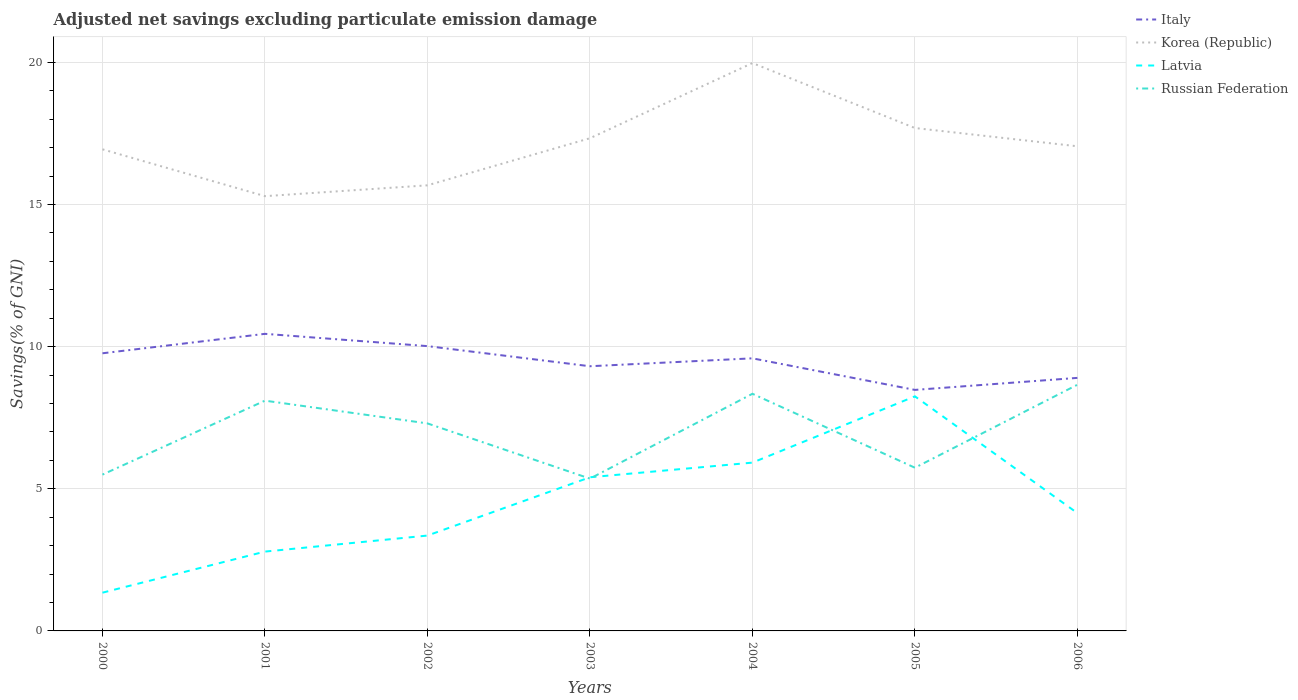How many different coloured lines are there?
Make the answer very short. 4. Across all years, what is the maximum adjusted net savings in Italy?
Your response must be concise. 8.48. What is the total adjusted net savings in Latvia in the graph?
Offer a terse response. 1.78. What is the difference between the highest and the second highest adjusted net savings in Korea (Republic)?
Your answer should be very brief. 4.68. Is the adjusted net savings in Russian Federation strictly greater than the adjusted net savings in Korea (Republic) over the years?
Keep it short and to the point. Yes. How many lines are there?
Your answer should be compact. 4. Does the graph contain any zero values?
Provide a succinct answer. No. Does the graph contain grids?
Make the answer very short. Yes. Where does the legend appear in the graph?
Your answer should be compact. Top right. How many legend labels are there?
Ensure brevity in your answer.  4. What is the title of the graph?
Ensure brevity in your answer.  Adjusted net savings excluding particulate emission damage. Does "Kazakhstan" appear as one of the legend labels in the graph?
Your answer should be very brief. No. What is the label or title of the Y-axis?
Provide a short and direct response. Savings(% of GNI). What is the Savings(% of GNI) of Italy in 2000?
Ensure brevity in your answer.  9.77. What is the Savings(% of GNI) in Korea (Republic) in 2000?
Provide a succinct answer. 16.94. What is the Savings(% of GNI) of Latvia in 2000?
Offer a very short reply. 1.35. What is the Savings(% of GNI) in Russian Federation in 2000?
Give a very brief answer. 5.5. What is the Savings(% of GNI) of Italy in 2001?
Give a very brief answer. 10.45. What is the Savings(% of GNI) in Korea (Republic) in 2001?
Your response must be concise. 15.29. What is the Savings(% of GNI) of Latvia in 2001?
Your answer should be compact. 2.79. What is the Savings(% of GNI) of Russian Federation in 2001?
Provide a short and direct response. 8.1. What is the Savings(% of GNI) of Italy in 2002?
Your answer should be compact. 10.02. What is the Savings(% of GNI) of Korea (Republic) in 2002?
Provide a succinct answer. 15.67. What is the Savings(% of GNI) in Latvia in 2002?
Ensure brevity in your answer.  3.35. What is the Savings(% of GNI) of Russian Federation in 2002?
Provide a short and direct response. 7.3. What is the Savings(% of GNI) of Italy in 2003?
Your answer should be very brief. 9.31. What is the Savings(% of GNI) of Korea (Republic) in 2003?
Make the answer very short. 17.33. What is the Savings(% of GNI) in Latvia in 2003?
Your answer should be very brief. 5.41. What is the Savings(% of GNI) of Russian Federation in 2003?
Provide a succinct answer. 5.36. What is the Savings(% of GNI) of Italy in 2004?
Make the answer very short. 9.59. What is the Savings(% of GNI) of Korea (Republic) in 2004?
Your response must be concise. 19.98. What is the Savings(% of GNI) in Latvia in 2004?
Your answer should be very brief. 5.92. What is the Savings(% of GNI) in Russian Federation in 2004?
Provide a short and direct response. 8.34. What is the Savings(% of GNI) of Italy in 2005?
Make the answer very short. 8.48. What is the Savings(% of GNI) of Korea (Republic) in 2005?
Offer a very short reply. 17.69. What is the Savings(% of GNI) of Latvia in 2005?
Your answer should be compact. 8.25. What is the Savings(% of GNI) of Russian Federation in 2005?
Your answer should be compact. 5.74. What is the Savings(% of GNI) of Italy in 2006?
Make the answer very short. 8.9. What is the Savings(% of GNI) in Korea (Republic) in 2006?
Provide a succinct answer. 17.05. What is the Savings(% of GNI) in Latvia in 2006?
Keep it short and to the point. 4.14. What is the Savings(% of GNI) of Russian Federation in 2006?
Give a very brief answer. 8.66. Across all years, what is the maximum Savings(% of GNI) in Italy?
Your answer should be compact. 10.45. Across all years, what is the maximum Savings(% of GNI) of Korea (Republic)?
Make the answer very short. 19.98. Across all years, what is the maximum Savings(% of GNI) in Latvia?
Your answer should be very brief. 8.25. Across all years, what is the maximum Savings(% of GNI) of Russian Federation?
Offer a very short reply. 8.66. Across all years, what is the minimum Savings(% of GNI) in Italy?
Provide a succinct answer. 8.48. Across all years, what is the minimum Savings(% of GNI) in Korea (Republic)?
Keep it short and to the point. 15.29. Across all years, what is the minimum Savings(% of GNI) of Latvia?
Offer a terse response. 1.35. Across all years, what is the minimum Savings(% of GNI) of Russian Federation?
Your answer should be very brief. 5.36. What is the total Savings(% of GNI) in Italy in the graph?
Ensure brevity in your answer.  66.51. What is the total Savings(% of GNI) in Korea (Republic) in the graph?
Your answer should be compact. 119.95. What is the total Savings(% of GNI) in Latvia in the graph?
Your answer should be very brief. 31.21. What is the total Savings(% of GNI) in Russian Federation in the graph?
Your answer should be very brief. 49. What is the difference between the Savings(% of GNI) in Italy in 2000 and that in 2001?
Offer a terse response. -0.68. What is the difference between the Savings(% of GNI) of Korea (Republic) in 2000 and that in 2001?
Keep it short and to the point. 1.65. What is the difference between the Savings(% of GNI) in Latvia in 2000 and that in 2001?
Provide a short and direct response. -1.45. What is the difference between the Savings(% of GNI) in Russian Federation in 2000 and that in 2001?
Your response must be concise. -2.6. What is the difference between the Savings(% of GNI) in Italy in 2000 and that in 2002?
Make the answer very short. -0.25. What is the difference between the Savings(% of GNI) in Korea (Republic) in 2000 and that in 2002?
Provide a succinct answer. 1.27. What is the difference between the Savings(% of GNI) of Latvia in 2000 and that in 2002?
Offer a very short reply. -2.01. What is the difference between the Savings(% of GNI) of Russian Federation in 2000 and that in 2002?
Your response must be concise. -1.8. What is the difference between the Savings(% of GNI) in Italy in 2000 and that in 2003?
Provide a short and direct response. 0.46. What is the difference between the Savings(% of GNI) of Korea (Republic) in 2000 and that in 2003?
Offer a terse response. -0.39. What is the difference between the Savings(% of GNI) in Latvia in 2000 and that in 2003?
Ensure brevity in your answer.  -4.06. What is the difference between the Savings(% of GNI) in Russian Federation in 2000 and that in 2003?
Your answer should be compact. 0.14. What is the difference between the Savings(% of GNI) in Italy in 2000 and that in 2004?
Offer a very short reply. 0.18. What is the difference between the Savings(% of GNI) in Korea (Republic) in 2000 and that in 2004?
Give a very brief answer. -3.03. What is the difference between the Savings(% of GNI) in Latvia in 2000 and that in 2004?
Provide a succinct answer. -4.57. What is the difference between the Savings(% of GNI) of Russian Federation in 2000 and that in 2004?
Offer a terse response. -2.84. What is the difference between the Savings(% of GNI) of Italy in 2000 and that in 2005?
Offer a terse response. 1.29. What is the difference between the Savings(% of GNI) in Korea (Republic) in 2000 and that in 2005?
Your answer should be compact. -0.75. What is the difference between the Savings(% of GNI) of Latvia in 2000 and that in 2005?
Your response must be concise. -6.91. What is the difference between the Savings(% of GNI) of Russian Federation in 2000 and that in 2005?
Provide a short and direct response. -0.24. What is the difference between the Savings(% of GNI) of Italy in 2000 and that in 2006?
Make the answer very short. 0.87. What is the difference between the Savings(% of GNI) of Korea (Republic) in 2000 and that in 2006?
Provide a short and direct response. -0.11. What is the difference between the Savings(% of GNI) in Latvia in 2000 and that in 2006?
Give a very brief answer. -2.8. What is the difference between the Savings(% of GNI) in Russian Federation in 2000 and that in 2006?
Ensure brevity in your answer.  -3.16. What is the difference between the Savings(% of GNI) in Italy in 2001 and that in 2002?
Ensure brevity in your answer.  0.43. What is the difference between the Savings(% of GNI) of Korea (Republic) in 2001 and that in 2002?
Provide a short and direct response. -0.38. What is the difference between the Savings(% of GNI) in Latvia in 2001 and that in 2002?
Provide a short and direct response. -0.56. What is the difference between the Savings(% of GNI) of Russian Federation in 2001 and that in 2002?
Give a very brief answer. 0.8. What is the difference between the Savings(% of GNI) in Italy in 2001 and that in 2003?
Offer a very short reply. 1.14. What is the difference between the Savings(% of GNI) of Korea (Republic) in 2001 and that in 2003?
Your response must be concise. -2.04. What is the difference between the Savings(% of GNI) of Latvia in 2001 and that in 2003?
Give a very brief answer. -2.61. What is the difference between the Savings(% of GNI) of Russian Federation in 2001 and that in 2003?
Make the answer very short. 2.74. What is the difference between the Savings(% of GNI) in Italy in 2001 and that in 2004?
Give a very brief answer. 0.86. What is the difference between the Savings(% of GNI) in Korea (Republic) in 2001 and that in 2004?
Your answer should be very brief. -4.68. What is the difference between the Savings(% of GNI) of Latvia in 2001 and that in 2004?
Keep it short and to the point. -3.13. What is the difference between the Savings(% of GNI) of Russian Federation in 2001 and that in 2004?
Offer a very short reply. -0.24. What is the difference between the Savings(% of GNI) of Italy in 2001 and that in 2005?
Make the answer very short. 1.97. What is the difference between the Savings(% of GNI) of Korea (Republic) in 2001 and that in 2005?
Provide a short and direct response. -2.4. What is the difference between the Savings(% of GNI) of Latvia in 2001 and that in 2005?
Provide a succinct answer. -5.46. What is the difference between the Savings(% of GNI) of Russian Federation in 2001 and that in 2005?
Your response must be concise. 2.36. What is the difference between the Savings(% of GNI) in Italy in 2001 and that in 2006?
Your answer should be very brief. 1.55. What is the difference between the Savings(% of GNI) in Korea (Republic) in 2001 and that in 2006?
Provide a succinct answer. -1.75. What is the difference between the Savings(% of GNI) of Latvia in 2001 and that in 2006?
Ensure brevity in your answer.  -1.35. What is the difference between the Savings(% of GNI) of Russian Federation in 2001 and that in 2006?
Your response must be concise. -0.56. What is the difference between the Savings(% of GNI) of Italy in 2002 and that in 2003?
Give a very brief answer. 0.71. What is the difference between the Savings(% of GNI) in Korea (Republic) in 2002 and that in 2003?
Make the answer very short. -1.66. What is the difference between the Savings(% of GNI) in Latvia in 2002 and that in 2003?
Give a very brief answer. -2.05. What is the difference between the Savings(% of GNI) in Russian Federation in 2002 and that in 2003?
Give a very brief answer. 1.94. What is the difference between the Savings(% of GNI) of Italy in 2002 and that in 2004?
Provide a succinct answer. 0.43. What is the difference between the Savings(% of GNI) in Korea (Republic) in 2002 and that in 2004?
Provide a succinct answer. -4.3. What is the difference between the Savings(% of GNI) in Latvia in 2002 and that in 2004?
Provide a succinct answer. -2.57. What is the difference between the Savings(% of GNI) in Russian Federation in 2002 and that in 2004?
Give a very brief answer. -1.04. What is the difference between the Savings(% of GNI) of Italy in 2002 and that in 2005?
Ensure brevity in your answer.  1.54. What is the difference between the Savings(% of GNI) of Korea (Republic) in 2002 and that in 2005?
Give a very brief answer. -2.02. What is the difference between the Savings(% of GNI) of Latvia in 2002 and that in 2005?
Ensure brevity in your answer.  -4.9. What is the difference between the Savings(% of GNI) in Russian Federation in 2002 and that in 2005?
Keep it short and to the point. 1.56. What is the difference between the Savings(% of GNI) of Italy in 2002 and that in 2006?
Provide a succinct answer. 1.12. What is the difference between the Savings(% of GNI) in Korea (Republic) in 2002 and that in 2006?
Keep it short and to the point. -1.37. What is the difference between the Savings(% of GNI) of Latvia in 2002 and that in 2006?
Your response must be concise. -0.79. What is the difference between the Savings(% of GNI) of Russian Federation in 2002 and that in 2006?
Keep it short and to the point. -1.36. What is the difference between the Savings(% of GNI) of Italy in 2003 and that in 2004?
Offer a very short reply. -0.28. What is the difference between the Savings(% of GNI) in Korea (Republic) in 2003 and that in 2004?
Your answer should be very brief. -2.64. What is the difference between the Savings(% of GNI) of Latvia in 2003 and that in 2004?
Your answer should be compact. -0.51. What is the difference between the Savings(% of GNI) of Russian Federation in 2003 and that in 2004?
Your answer should be compact. -2.98. What is the difference between the Savings(% of GNI) of Italy in 2003 and that in 2005?
Give a very brief answer. 0.83. What is the difference between the Savings(% of GNI) in Korea (Republic) in 2003 and that in 2005?
Your answer should be compact. -0.36. What is the difference between the Savings(% of GNI) of Latvia in 2003 and that in 2005?
Your answer should be very brief. -2.85. What is the difference between the Savings(% of GNI) in Russian Federation in 2003 and that in 2005?
Give a very brief answer. -0.38. What is the difference between the Savings(% of GNI) of Italy in 2003 and that in 2006?
Provide a short and direct response. 0.41. What is the difference between the Savings(% of GNI) in Korea (Republic) in 2003 and that in 2006?
Keep it short and to the point. 0.28. What is the difference between the Savings(% of GNI) in Latvia in 2003 and that in 2006?
Provide a short and direct response. 1.26. What is the difference between the Savings(% of GNI) in Russian Federation in 2003 and that in 2006?
Your answer should be very brief. -3.3. What is the difference between the Savings(% of GNI) in Italy in 2004 and that in 2005?
Offer a terse response. 1.11. What is the difference between the Savings(% of GNI) in Korea (Republic) in 2004 and that in 2005?
Provide a succinct answer. 2.29. What is the difference between the Savings(% of GNI) of Latvia in 2004 and that in 2005?
Offer a terse response. -2.33. What is the difference between the Savings(% of GNI) in Russian Federation in 2004 and that in 2005?
Keep it short and to the point. 2.6. What is the difference between the Savings(% of GNI) in Italy in 2004 and that in 2006?
Give a very brief answer. 0.69. What is the difference between the Savings(% of GNI) in Korea (Republic) in 2004 and that in 2006?
Provide a short and direct response. 2.93. What is the difference between the Savings(% of GNI) of Latvia in 2004 and that in 2006?
Your answer should be compact. 1.78. What is the difference between the Savings(% of GNI) in Russian Federation in 2004 and that in 2006?
Make the answer very short. -0.32. What is the difference between the Savings(% of GNI) of Italy in 2005 and that in 2006?
Your response must be concise. -0.42. What is the difference between the Savings(% of GNI) in Korea (Republic) in 2005 and that in 2006?
Provide a succinct answer. 0.64. What is the difference between the Savings(% of GNI) of Latvia in 2005 and that in 2006?
Ensure brevity in your answer.  4.11. What is the difference between the Savings(% of GNI) in Russian Federation in 2005 and that in 2006?
Offer a terse response. -2.92. What is the difference between the Savings(% of GNI) of Italy in 2000 and the Savings(% of GNI) of Korea (Republic) in 2001?
Make the answer very short. -5.53. What is the difference between the Savings(% of GNI) of Italy in 2000 and the Savings(% of GNI) of Latvia in 2001?
Ensure brevity in your answer.  6.98. What is the difference between the Savings(% of GNI) in Italy in 2000 and the Savings(% of GNI) in Russian Federation in 2001?
Your answer should be very brief. 1.67. What is the difference between the Savings(% of GNI) of Korea (Republic) in 2000 and the Savings(% of GNI) of Latvia in 2001?
Offer a very short reply. 14.15. What is the difference between the Savings(% of GNI) in Korea (Republic) in 2000 and the Savings(% of GNI) in Russian Federation in 2001?
Make the answer very short. 8.84. What is the difference between the Savings(% of GNI) in Latvia in 2000 and the Savings(% of GNI) in Russian Federation in 2001?
Give a very brief answer. -6.75. What is the difference between the Savings(% of GNI) in Italy in 2000 and the Savings(% of GNI) in Korea (Republic) in 2002?
Your answer should be compact. -5.91. What is the difference between the Savings(% of GNI) of Italy in 2000 and the Savings(% of GNI) of Latvia in 2002?
Provide a succinct answer. 6.41. What is the difference between the Savings(% of GNI) of Italy in 2000 and the Savings(% of GNI) of Russian Federation in 2002?
Your response must be concise. 2.47. What is the difference between the Savings(% of GNI) of Korea (Republic) in 2000 and the Savings(% of GNI) of Latvia in 2002?
Ensure brevity in your answer.  13.59. What is the difference between the Savings(% of GNI) in Korea (Republic) in 2000 and the Savings(% of GNI) in Russian Federation in 2002?
Provide a succinct answer. 9.64. What is the difference between the Savings(% of GNI) of Latvia in 2000 and the Savings(% of GNI) of Russian Federation in 2002?
Provide a succinct answer. -5.95. What is the difference between the Savings(% of GNI) in Italy in 2000 and the Savings(% of GNI) in Korea (Republic) in 2003?
Ensure brevity in your answer.  -7.56. What is the difference between the Savings(% of GNI) in Italy in 2000 and the Savings(% of GNI) in Latvia in 2003?
Your response must be concise. 4.36. What is the difference between the Savings(% of GNI) of Italy in 2000 and the Savings(% of GNI) of Russian Federation in 2003?
Offer a terse response. 4.41. What is the difference between the Savings(% of GNI) in Korea (Republic) in 2000 and the Savings(% of GNI) in Latvia in 2003?
Your response must be concise. 11.54. What is the difference between the Savings(% of GNI) of Korea (Republic) in 2000 and the Savings(% of GNI) of Russian Federation in 2003?
Provide a succinct answer. 11.58. What is the difference between the Savings(% of GNI) in Latvia in 2000 and the Savings(% of GNI) in Russian Federation in 2003?
Provide a short and direct response. -4.01. What is the difference between the Savings(% of GNI) of Italy in 2000 and the Savings(% of GNI) of Korea (Republic) in 2004?
Offer a very short reply. -10.21. What is the difference between the Savings(% of GNI) in Italy in 2000 and the Savings(% of GNI) in Latvia in 2004?
Your answer should be compact. 3.85. What is the difference between the Savings(% of GNI) of Italy in 2000 and the Savings(% of GNI) of Russian Federation in 2004?
Provide a short and direct response. 1.42. What is the difference between the Savings(% of GNI) in Korea (Republic) in 2000 and the Savings(% of GNI) in Latvia in 2004?
Give a very brief answer. 11.02. What is the difference between the Savings(% of GNI) of Korea (Republic) in 2000 and the Savings(% of GNI) of Russian Federation in 2004?
Ensure brevity in your answer.  8.6. What is the difference between the Savings(% of GNI) of Latvia in 2000 and the Savings(% of GNI) of Russian Federation in 2004?
Your answer should be very brief. -7. What is the difference between the Savings(% of GNI) in Italy in 2000 and the Savings(% of GNI) in Korea (Republic) in 2005?
Provide a short and direct response. -7.92. What is the difference between the Savings(% of GNI) of Italy in 2000 and the Savings(% of GNI) of Latvia in 2005?
Offer a very short reply. 1.51. What is the difference between the Savings(% of GNI) of Italy in 2000 and the Savings(% of GNI) of Russian Federation in 2005?
Make the answer very short. 4.03. What is the difference between the Savings(% of GNI) in Korea (Republic) in 2000 and the Savings(% of GNI) in Latvia in 2005?
Provide a succinct answer. 8.69. What is the difference between the Savings(% of GNI) in Latvia in 2000 and the Savings(% of GNI) in Russian Federation in 2005?
Your answer should be very brief. -4.4. What is the difference between the Savings(% of GNI) of Italy in 2000 and the Savings(% of GNI) of Korea (Republic) in 2006?
Give a very brief answer. -7.28. What is the difference between the Savings(% of GNI) of Italy in 2000 and the Savings(% of GNI) of Latvia in 2006?
Ensure brevity in your answer.  5.62. What is the difference between the Savings(% of GNI) in Italy in 2000 and the Savings(% of GNI) in Russian Federation in 2006?
Your response must be concise. 1.11. What is the difference between the Savings(% of GNI) in Korea (Republic) in 2000 and the Savings(% of GNI) in Latvia in 2006?
Offer a terse response. 12.8. What is the difference between the Savings(% of GNI) in Korea (Republic) in 2000 and the Savings(% of GNI) in Russian Federation in 2006?
Offer a terse response. 8.28. What is the difference between the Savings(% of GNI) of Latvia in 2000 and the Savings(% of GNI) of Russian Federation in 2006?
Offer a very short reply. -7.31. What is the difference between the Savings(% of GNI) of Italy in 2001 and the Savings(% of GNI) of Korea (Republic) in 2002?
Provide a short and direct response. -5.22. What is the difference between the Savings(% of GNI) of Italy in 2001 and the Savings(% of GNI) of Latvia in 2002?
Your answer should be compact. 7.1. What is the difference between the Savings(% of GNI) of Italy in 2001 and the Savings(% of GNI) of Russian Federation in 2002?
Keep it short and to the point. 3.15. What is the difference between the Savings(% of GNI) in Korea (Republic) in 2001 and the Savings(% of GNI) in Latvia in 2002?
Offer a very short reply. 11.94. What is the difference between the Savings(% of GNI) in Korea (Republic) in 2001 and the Savings(% of GNI) in Russian Federation in 2002?
Your response must be concise. 7.99. What is the difference between the Savings(% of GNI) of Latvia in 2001 and the Savings(% of GNI) of Russian Federation in 2002?
Give a very brief answer. -4.51. What is the difference between the Savings(% of GNI) in Italy in 2001 and the Savings(% of GNI) in Korea (Republic) in 2003?
Offer a very short reply. -6.88. What is the difference between the Savings(% of GNI) in Italy in 2001 and the Savings(% of GNI) in Latvia in 2003?
Make the answer very short. 5.04. What is the difference between the Savings(% of GNI) of Italy in 2001 and the Savings(% of GNI) of Russian Federation in 2003?
Your answer should be very brief. 5.09. What is the difference between the Savings(% of GNI) in Korea (Republic) in 2001 and the Savings(% of GNI) in Latvia in 2003?
Give a very brief answer. 9.89. What is the difference between the Savings(% of GNI) in Korea (Republic) in 2001 and the Savings(% of GNI) in Russian Federation in 2003?
Make the answer very short. 9.94. What is the difference between the Savings(% of GNI) in Latvia in 2001 and the Savings(% of GNI) in Russian Federation in 2003?
Your response must be concise. -2.57. What is the difference between the Savings(% of GNI) in Italy in 2001 and the Savings(% of GNI) in Korea (Republic) in 2004?
Your answer should be compact. -9.53. What is the difference between the Savings(% of GNI) in Italy in 2001 and the Savings(% of GNI) in Latvia in 2004?
Ensure brevity in your answer.  4.53. What is the difference between the Savings(% of GNI) in Italy in 2001 and the Savings(% of GNI) in Russian Federation in 2004?
Make the answer very short. 2.11. What is the difference between the Savings(% of GNI) of Korea (Republic) in 2001 and the Savings(% of GNI) of Latvia in 2004?
Keep it short and to the point. 9.37. What is the difference between the Savings(% of GNI) of Korea (Republic) in 2001 and the Savings(% of GNI) of Russian Federation in 2004?
Keep it short and to the point. 6.95. What is the difference between the Savings(% of GNI) in Latvia in 2001 and the Savings(% of GNI) in Russian Federation in 2004?
Offer a terse response. -5.55. What is the difference between the Savings(% of GNI) of Italy in 2001 and the Savings(% of GNI) of Korea (Republic) in 2005?
Offer a terse response. -7.24. What is the difference between the Savings(% of GNI) of Italy in 2001 and the Savings(% of GNI) of Latvia in 2005?
Provide a succinct answer. 2.2. What is the difference between the Savings(% of GNI) in Italy in 2001 and the Savings(% of GNI) in Russian Federation in 2005?
Offer a terse response. 4.71. What is the difference between the Savings(% of GNI) in Korea (Republic) in 2001 and the Savings(% of GNI) in Latvia in 2005?
Give a very brief answer. 7.04. What is the difference between the Savings(% of GNI) of Korea (Republic) in 2001 and the Savings(% of GNI) of Russian Federation in 2005?
Give a very brief answer. 9.55. What is the difference between the Savings(% of GNI) of Latvia in 2001 and the Savings(% of GNI) of Russian Federation in 2005?
Provide a short and direct response. -2.95. What is the difference between the Savings(% of GNI) in Italy in 2001 and the Savings(% of GNI) in Korea (Republic) in 2006?
Make the answer very short. -6.6. What is the difference between the Savings(% of GNI) in Italy in 2001 and the Savings(% of GNI) in Latvia in 2006?
Provide a short and direct response. 6.31. What is the difference between the Savings(% of GNI) of Italy in 2001 and the Savings(% of GNI) of Russian Federation in 2006?
Your answer should be compact. 1.79. What is the difference between the Savings(% of GNI) in Korea (Republic) in 2001 and the Savings(% of GNI) in Latvia in 2006?
Make the answer very short. 11.15. What is the difference between the Savings(% of GNI) of Korea (Republic) in 2001 and the Savings(% of GNI) of Russian Federation in 2006?
Give a very brief answer. 6.63. What is the difference between the Savings(% of GNI) in Latvia in 2001 and the Savings(% of GNI) in Russian Federation in 2006?
Offer a terse response. -5.87. What is the difference between the Savings(% of GNI) in Italy in 2002 and the Savings(% of GNI) in Korea (Republic) in 2003?
Provide a succinct answer. -7.31. What is the difference between the Savings(% of GNI) of Italy in 2002 and the Savings(% of GNI) of Latvia in 2003?
Offer a very short reply. 4.61. What is the difference between the Savings(% of GNI) in Italy in 2002 and the Savings(% of GNI) in Russian Federation in 2003?
Provide a short and direct response. 4.66. What is the difference between the Savings(% of GNI) in Korea (Republic) in 2002 and the Savings(% of GNI) in Latvia in 2003?
Make the answer very short. 10.27. What is the difference between the Savings(% of GNI) in Korea (Republic) in 2002 and the Savings(% of GNI) in Russian Federation in 2003?
Your response must be concise. 10.32. What is the difference between the Savings(% of GNI) of Latvia in 2002 and the Savings(% of GNI) of Russian Federation in 2003?
Provide a short and direct response. -2. What is the difference between the Savings(% of GNI) of Italy in 2002 and the Savings(% of GNI) of Korea (Republic) in 2004?
Your response must be concise. -9.96. What is the difference between the Savings(% of GNI) of Italy in 2002 and the Savings(% of GNI) of Latvia in 2004?
Ensure brevity in your answer.  4.1. What is the difference between the Savings(% of GNI) in Italy in 2002 and the Savings(% of GNI) in Russian Federation in 2004?
Make the answer very short. 1.68. What is the difference between the Savings(% of GNI) in Korea (Republic) in 2002 and the Savings(% of GNI) in Latvia in 2004?
Your answer should be compact. 9.75. What is the difference between the Savings(% of GNI) of Korea (Republic) in 2002 and the Savings(% of GNI) of Russian Federation in 2004?
Ensure brevity in your answer.  7.33. What is the difference between the Savings(% of GNI) of Latvia in 2002 and the Savings(% of GNI) of Russian Federation in 2004?
Provide a short and direct response. -4.99. What is the difference between the Savings(% of GNI) in Italy in 2002 and the Savings(% of GNI) in Korea (Republic) in 2005?
Offer a terse response. -7.67. What is the difference between the Savings(% of GNI) in Italy in 2002 and the Savings(% of GNI) in Latvia in 2005?
Your response must be concise. 1.77. What is the difference between the Savings(% of GNI) of Italy in 2002 and the Savings(% of GNI) of Russian Federation in 2005?
Your answer should be very brief. 4.28. What is the difference between the Savings(% of GNI) in Korea (Republic) in 2002 and the Savings(% of GNI) in Latvia in 2005?
Make the answer very short. 7.42. What is the difference between the Savings(% of GNI) of Korea (Republic) in 2002 and the Savings(% of GNI) of Russian Federation in 2005?
Give a very brief answer. 9.93. What is the difference between the Savings(% of GNI) of Latvia in 2002 and the Savings(% of GNI) of Russian Federation in 2005?
Provide a short and direct response. -2.39. What is the difference between the Savings(% of GNI) of Italy in 2002 and the Savings(% of GNI) of Korea (Republic) in 2006?
Provide a short and direct response. -7.03. What is the difference between the Savings(% of GNI) in Italy in 2002 and the Savings(% of GNI) in Latvia in 2006?
Provide a short and direct response. 5.87. What is the difference between the Savings(% of GNI) in Italy in 2002 and the Savings(% of GNI) in Russian Federation in 2006?
Offer a very short reply. 1.36. What is the difference between the Savings(% of GNI) in Korea (Republic) in 2002 and the Savings(% of GNI) in Latvia in 2006?
Offer a terse response. 11.53. What is the difference between the Savings(% of GNI) in Korea (Republic) in 2002 and the Savings(% of GNI) in Russian Federation in 2006?
Offer a terse response. 7.01. What is the difference between the Savings(% of GNI) of Latvia in 2002 and the Savings(% of GNI) of Russian Federation in 2006?
Ensure brevity in your answer.  -5.31. What is the difference between the Savings(% of GNI) in Italy in 2003 and the Savings(% of GNI) in Korea (Republic) in 2004?
Provide a succinct answer. -10.66. What is the difference between the Savings(% of GNI) in Italy in 2003 and the Savings(% of GNI) in Latvia in 2004?
Your response must be concise. 3.39. What is the difference between the Savings(% of GNI) in Italy in 2003 and the Savings(% of GNI) in Russian Federation in 2004?
Your response must be concise. 0.97. What is the difference between the Savings(% of GNI) of Korea (Republic) in 2003 and the Savings(% of GNI) of Latvia in 2004?
Give a very brief answer. 11.41. What is the difference between the Savings(% of GNI) of Korea (Republic) in 2003 and the Savings(% of GNI) of Russian Federation in 2004?
Your answer should be very brief. 8.99. What is the difference between the Savings(% of GNI) in Latvia in 2003 and the Savings(% of GNI) in Russian Federation in 2004?
Keep it short and to the point. -2.94. What is the difference between the Savings(% of GNI) of Italy in 2003 and the Savings(% of GNI) of Korea (Republic) in 2005?
Provide a short and direct response. -8.38. What is the difference between the Savings(% of GNI) of Italy in 2003 and the Savings(% of GNI) of Latvia in 2005?
Your answer should be very brief. 1.06. What is the difference between the Savings(% of GNI) of Italy in 2003 and the Savings(% of GNI) of Russian Federation in 2005?
Provide a succinct answer. 3.57. What is the difference between the Savings(% of GNI) in Korea (Republic) in 2003 and the Savings(% of GNI) in Latvia in 2005?
Make the answer very short. 9.08. What is the difference between the Savings(% of GNI) in Korea (Republic) in 2003 and the Savings(% of GNI) in Russian Federation in 2005?
Your answer should be compact. 11.59. What is the difference between the Savings(% of GNI) of Latvia in 2003 and the Savings(% of GNI) of Russian Federation in 2005?
Keep it short and to the point. -0.34. What is the difference between the Savings(% of GNI) in Italy in 2003 and the Savings(% of GNI) in Korea (Republic) in 2006?
Your answer should be very brief. -7.74. What is the difference between the Savings(% of GNI) in Italy in 2003 and the Savings(% of GNI) in Latvia in 2006?
Your response must be concise. 5.17. What is the difference between the Savings(% of GNI) in Italy in 2003 and the Savings(% of GNI) in Russian Federation in 2006?
Make the answer very short. 0.65. What is the difference between the Savings(% of GNI) in Korea (Republic) in 2003 and the Savings(% of GNI) in Latvia in 2006?
Your answer should be very brief. 13.19. What is the difference between the Savings(% of GNI) in Korea (Republic) in 2003 and the Savings(% of GNI) in Russian Federation in 2006?
Keep it short and to the point. 8.67. What is the difference between the Savings(% of GNI) of Latvia in 2003 and the Savings(% of GNI) of Russian Federation in 2006?
Your answer should be very brief. -3.25. What is the difference between the Savings(% of GNI) of Italy in 2004 and the Savings(% of GNI) of Korea (Republic) in 2005?
Offer a very short reply. -8.1. What is the difference between the Savings(% of GNI) of Italy in 2004 and the Savings(% of GNI) of Latvia in 2005?
Provide a succinct answer. 1.34. What is the difference between the Savings(% of GNI) in Italy in 2004 and the Savings(% of GNI) in Russian Federation in 2005?
Ensure brevity in your answer.  3.85. What is the difference between the Savings(% of GNI) in Korea (Republic) in 2004 and the Savings(% of GNI) in Latvia in 2005?
Your response must be concise. 11.72. What is the difference between the Savings(% of GNI) in Korea (Republic) in 2004 and the Savings(% of GNI) in Russian Federation in 2005?
Make the answer very short. 14.23. What is the difference between the Savings(% of GNI) of Latvia in 2004 and the Savings(% of GNI) of Russian Federation in 2005?
Make the answer very short. 0.18. What is the difference between the Savings(% of GNI) of Italy in 2004 and the Savings(% of GNI) of Korea (Republic) in 2006?
Offer a very short reply. -7.46. What is the difference between the Savings(% of GNI) of Italy in 2004 and the Savings(% of GNI) of Latvia in 2006?
Provide a succinct answer. 5.44. What is the difference between the Savings(% of GNI) in Italy in 2004 and the Savings(% of GNI) in Russian Federation in 2006?
Your answer should be very brief. 0.93. What is the difference between the Savings(% of GNI) in Korea (Republic) in 2004 and the Savings(% of GNI) in Latvia in 2006?
Provide a succinct answer. 15.83. What is the difference between the Savings(% of GNI) of Korea (Republic) in 2004 and the Savings(% of GNI) of Russian Federation in 2006?
Offer a very short reply. 11.32. What is the difference between the Savings(% of GNI) of Latvia in 2004 and the Savings(% of GNI) of Russian Federation in 2006?
Your answer should be very brief. -2.74. What is the difference between the Savings(% of GNI) in Italy in 2005 and the Savings(% of GNI) in Korea (Republic) in 2006?
Ensure brevity in your answer.  -8.57. What is the difference between the Savings(% of GNI) of Italy in 2005 and the Savings(% of GNI) of Latvia in 2006?
Your answer should be very brief. 4.33. What is the difference between the Savings(% of GNI) in Italy in 2005 and the Savings(% of GNI) in Russian Federation in 2006?
Make the answer very short. -0.18. What is the difference between the Savings(% of GNI) of Korea (Republic) in 2005 and the Savings(% of GNI) of Latvia in 2006?
Your answer should be very brief. 13.55. What is the difference between the Savings(% of GNI) of Korea (Republic) in 2005 and the Savings(% of GNI) of Russian Federation in 2006?
Offer a very short reply. 9.03. What is the difference between the Savings(% of GNI) in Latvia in 2005 and the Savings(% of GNI) in Russian Federation in 2006?
Ensure brevity in your answer.  -0.41. What is the average Savings(% of GNI) in Italy per year?
Your answer should be very brief. 9.5. What is the average Savings(% of GNI) of Korea (Republic) per year?
Your response must be concise. 17.14. What is the average Savings(% of GNI) of Latvia per year?
Provide a short and direct response. 4.46. What is the average Savings(% of GNI) of Russian Federation per year?
Provide a succinct answer. 7. In the year 2000, what is the difference between the Savings(% of GNI) in Italy and Savings(% of GNI) in Korea (Republic)?
Provide a short and direct response. -7.17. In the year 2000, what is the difference between the Savings(% of GNI) of Italy and Savings(% of GNI) of Latvia?
Keep it short and to the point. 8.42. In the year 2000, what is the difference between the Savings(% of GNI) in Italy and Savings(% of GNI) in Russian Federation?
Offer a very short reply. 4.27. In the year 2000, what is the difference between the Savings(% of GNI) in Korea (Republic) and Savings(% of GNI) in Latvia?
Offer a terse response. 15.6. In the year 2000, what is the difference between the Savings(% of GNI) of Korea (Republic) and Savings(% of GNI) of Russian Federation?
Provide a short and direct response. 11.44. In the year 2000, what is the difference between the Savings(% of GNI) of Latvia and Savings(% of GNI) of Russian Federation?
Give a very brief answer. -4.15. In the year 2001, what is the difference between the Savings(% of GNI) of Italy and Savings(% of GNI) of Korea (Republic)?
Offer a very short reply. -4.84. In the year 2001, what is the difference between the Savings(% of GNI) in Italy and Savings(% of GNI) in Latvia?
Your response must be concise. 7.66. In the year 2001, what is the difference between the Savings(% of GNI) of Italy and Savings(% of GNI) of Russian Federation?
Make the answer very short. 2.35. In the year 2001, what is the difference between the Savings(% of GNI) of Korea (Republic) and Savings(% of GNI) of Latvia?
Provide a short and direct response. 12.5. In the year 2001, what is the difference between the Savings(% of GNI) in Korea (Republic) and Savings(% of GNI) in Russian Federation?
Provide a succinct answer. 7.19. In the year 2001, what is the difference between the Savings(% of GNI) in Latvia and Savings(% of GNI) in Russian Federation?
Your answer should be compact. -5.31. In the year 2002, what is the difference between the Savings(% of GNI) in Italy and Savings(% of GNI) in Korea (Republic)?
Keep it short and to the point. -5.66. In the year 2002, what is the difference between the Savings(% of GNI) of Italy and Savings(% of GNI) of Latvia?
Offer a terse response. 6.66. In the year 2002, what is the difference between the Savings(% of GNI) of Italy and Savings(% of GNI) of Russian Federation?
Ensure brevity in your answer.  2.72. In the year 2002, what is the difference between the Savings(% of GNI) of Korea (Republic) and Savings(% of GNI) of Latvia?
Ensure brevity in your answer.  12.32. In the year 2002, what is the difference between the Savings(% of GNI) of Korea (Republic) and Savings(% of GNI) of Russian Federation?
Keep it short and to the point. 8.38. In the year 2002, what is the difference between the Savings(% of GNI) of Latvia and Savings(% of GNI) of Russian Federation?
Offer a terse response. -3.95. In the year 2003, what is the difference between the Savings(% of GNI) in Italy and Savings(% of GNI) in Korea (Republic)?
Give a very brief answer. -8.02. In the year 2003, what is the difference between the Savings(% of GNI) of Italy and Savings(% of GNI) of Latvia?
Provide a succinct answer. 3.91. In the year 2003, what is the difference between the Savings(% of GNI) in Italy and Savings(% of GNI) in Russian Federation?
Your answer should be compact. 3.95. In the year 2003, what is the difference between the Savings(% of GNI) in Korea (Republic) and Savings(% of GNI) in Latvia?
Ensure brevity in your answer.  11.93. In the year 2003, what is the difference between the Savings(% of GNI) of Korea (Republic) and Savings(% of GNI) of Russian Federation?
Make the answer very short. 11.97. In the year 2003, what is the difference between the Savings(% of GNI) of Latvia and Savings(% of GNI) of Russian Federation?
Give a very brief answer. 0.05. In the year 2004, what is the difference between the Savings(% of GNI) of Italy and Savings(% of GNI) of Korea (Republic)?
Provide a short and direct response. -10.39. In the year 2004, what is the difference between the Savings(% of GNI) of Italy and Savings(% of GNI) of Latvia?
Give a very brief answer. 3.67. In the year 2004, what is the difference between the Savings(% of GNI) in Italy and Savings(% of GNI) in Russian Federation?
Provide a succinct answer. 1.25. In the year 2004, what is the difference between the Savings(% of GNI) of Korea (Republic) and Savings(% of GNI) of Latvia?
Provide a short and direct response. 14.06. In the year 2004, what is the difference between the Savings(% of GNI) in Korea (Republic) and Savings(% of GNI) in Russian Federation?
Your response must be concise. 11.63. In the year 2004, what is the difference between the Savings(% of GNI) of Latvia and Savings(% of GNI) of Russian Federation?
Provide a succinct answer. -2.42. In the year 2005, what is the difference between the Savings(% of GNI) in Italy and Savings(% of GNI) in Korea (Republic)?
Your response must be concise. -9.21. In the year 2005, what is the difference between the Savings(% of GNI) of Italy and Savings(% of GNI) of Latvia?
Make the answer very short. 0.23. In the year 2005, what is the difference between the Savings(% of GNI) in Italy and Savings(% of GNI) in Russian Federation?
Your answer should be compact. 2.74. In the year 2005, what is the difference between the Savings(% of GNI) in Korea (Republic) and Savings(% of GNI) in Latvia?
Provide a short and direct response. 9.44. In the year 2005, what is the difference between the Savings(% of GNI) in Korea (Republic) and Savings(% of GNI) in Russian Federation?
Your answer should be very brief. 11.95. In the year 2005, what is the difference between the Savings(% of GNI) of Latvia and Savings(% of GNI) of Russian Federation?
Make the answer very short. 2.51. In the year 2006, what is the difference between the Savings(% of GNI) of Italy and Savings(% of GNI) of Korea (Republic)?
Make the answer very short. -8.15. In the year 2006, what is the difference between the Savings(% of GNI) of Italy and Savings(% of GNI) of Latvia?
Your answer should be compact. 4.76. In the year 2006, what is the difference between the Savings(% of GNI) of Italy and Savings(% of GNI) of Russian Federation?
Keep it short and to the point. 0.24. In the year 2006, what is the difference between the Savings(% of GNI) of Korea (Republic) and Savings(% of GNI) of Latvia?
Keep it short and to the point. 12.9. In the year 2006, what is the difference between the Savings(% of GNI) of Korea (Republic) and Savings(% of GNI) of Russian Federation?
Keep it short and to the point. 8.39. In the year 2006, what is the difference between the Savings(% of GNI) of Latvia and Savings(% of GNI) of Russian Federation?
Offer a very short reply. -4.52. What is the ratio of the Savings(% of GNI) in Italy in 2000 to that in 2001?
Offer a terse response. 0.93. What is the ratio of the Savings(% of GNI) of Korea (Republic) in 2000 to that in 2001?
Provide a succinct answer. 1.11. What is the ratio of the Savings(% of GNI) in Latvia in 2000 to that in 2001?
Make the answer very short. 0.48. What is the ratio of the Savings(% of GNI) in Russian Federation in 2000 to that in 2001?
Ensure brevity in your answer.  0.68. What is the ratio of the Savings(% of GNI) of Italy in 2000 to that in 2002?
Offer a very short reply. 0.97. What is the ratio of the Savings(% of GNI) of Korea (Republic) in 2000 to that in 2002?
Keep it short and to the point. 1.08. What is the ratio of the Savings(% of GNI) of Latvia in 2000 to that in 2002?
Your answer should be compact. 0.4. What is the ratio of the Savings(% of GNI) of Russian Federation in 2000 to that in 2002?
Provide a short and direct response. 0.75. What is the ratio of the Savings(% of GNI) of Italy in 2000 to that in 2003?
Make the answer very short. 1.05. What is the ratio of the Savings(% of GNI) in Korea (Republic) in 2000 to that in 2003?
Your response must be concise. 0.98. What is the ratio of the Savings(% of GNI) in Latvia in 2000 to that in 2003?
Ensure brevity in your answer.  0.25. What is the ratio of the Savings(% of GNI) in Russian Federation in 2000 to that in 2003?
Give a very brief answer. 1.03. What is the ratio of the Savings(% of GNI) in Italy in 2000 to that in 2004?
Give a very brief answer. 1.02. What is the ratio of the Savings(% of GNI) of Korea (Republic) in 2000 to that in 2004?
Your answer should be very brief. 0.85. What is the ratio of the Savings(% of GNI) of Latvia in 2000 to that in 2004?
Keep it short and to the point. 0.23. What is the ratio of the Savings(% of GNI) in Russian Federation in 2000 to that in 2004?
Provide a succinct answer. 0.66. What is the ratio of the Savings(% of GNI) of Italy in 2000 to that in 2005?
Give a very brief answer. 1.15. What is the ratio of the Savings(% of GNI) of Korea (Republic) in 2000 to that in 2005?
Provide a succinct answer. 0.96. What is the ratio of the Savings(% of GNI) of Latvia in 2000 to that in 2005?
Provide a short and direct response. 0.16. What is the ratio of the Savings(% of GNI) in Russian Federation in 2000 to that in 2005?
Your answer should be compact. 0.96. What is the ratio of the Savings(% of GNI) in Italy in 2000 to that in 2006?
Give a very brief answer. 1.1. What is the ratio of the Savings(% of GNI) in Korea (Republic) in 2000 to that in 2006?
Make the answer very short. 0.99. What is the ratio of the Savings(% of GNI) in Latvia in 2000 to that in 2006?
Offer a terse response. 0.32. What is the ratio of the Savings(% of GNI) in Russian Federation in 2000 to that in 2006?
Ensure brevity in your answer.  0.63. What is the ratio of the Savings(% of GNI) of Italy in 2001 to that in 2002?
Keep it short and to the point. 1.04. What is the ratio of the Savings(% of GNI) in Korea (Republic) in 2001 to that in 2002?
Your answer should be very brief. 0.98. What is the ratio of the Savings(% of GNI) in Latvia in 2001 to that in 2002?
Offer a terse response. 0.83. What is the ratio of the Savings(% of GNI) of Russian Federation in 2001 to that in 2002?
Your answer should be compact. 1.11. What is the ratio of the Savings(% of GNI) of Italy in 2001 to that in 2003?
Your answer should be compact. 1.12. What is the ratio of the Savings(% of GNI) in Korea (Republic) in 2001 to that in 2003?
Your response must be concise. 0.88. What is the ratio of the Savings(% of GNI) in Latvia in 2001 to that in 2003?
Make the answer very short. 0.52. What is the ratio of the Savings(% of GNI) in Russian Federation in 2001 to that in 2003?
Your answer should be very brief. 1.51. What is the ratio of the Savings(% of GNI) in Italy in 2001 to that in 2004?
Keep it short and to the point. 1.09. What is the ratio of the Savings(% of GNI) of Korea (Republic) in 2001 to that in 2004?
Your response must be concise. 0.77. What is the ratio of the Savings(% of GNI) in Latvia in 2001 to that in 2004?
Make the answer very short. 0.47. What is the ratio of the Savings(% of GNI) of Russian Federation in 2001 to that in 2004?
Keep it short and to the point. 0.97. What is the ratio of the Savings(% of GNI) of Italy in 2001 to that in 2005?
Your answer should be compact. 1.23. What is the ratio of the Savings(% of GNI) of Korea (Republic) in 2001 to that in 2005?
Your response must be concise. 0.86. What is the ratio of the Savings(% of GNI) in Latvia in 2001 to that in 2005?
Your answer should be very brief. 0.34. What is the ratio of the Savings(% of GNI) of Russian Federation in 2001 to that in 2005?
Offer a very short reply. 1.41. What is the ratio of the Savings(% of GNI) of Italy in 2001 to that in 2006?
Your answer should be compact. 1.17. What is the ratio of the Savings(% of GNI) of Korea (Republic) in 2001 to that in 2006?
Ensure brevity in your answer.  0.9. What is the ratio of the Savings(% of GNI) of Latvia in 2001 to that in 2006?
Provide a short and direct response. 0.67. What is the ratio of the Savings(% of GNI) in Russian Federation in 2001 to that in 2006?
Keep it short and to the point. 0.94. What is the ratio of the Savings(% of GNI) of Italy in 2002 to that in 2003?
Your answer should be compact. 1.08. What is the ratio of the Savings(% of GNI) of Korea (Republic) in 2002 to that in 2003?
Offer a terse response. 0.9. What is the ratio of the Savings(% of GNI) of Latvia in 2002 to that in 2003?
Give a very brief answer. 0.62. What is the ratio of the Savings(% of GNI) in Russian Federation in 2002 to that in 2003?
Your answer should be compact. 1.36. What is the ratio of the Savings(% of GNI) in Italy in 2002 to that in 2004?
Offer a terse response. 1.04. What is the ratio of the Savings(% of GNI) in Korea (Republic) in 2002 to that in 2004?
Your response must be concise. 0.78. What is the ratio of the Savings(% of GNI) of Latvia in 2002 to that in 2004?
Make the answer very short. 0.57. What is the ratio of the Savings(% of GNI) of Italy in 2002 to that in 2005?
Provide a succinct answer. 1.18. What is the ratio of the Savings(% of GNI) in Korea (Republic) in 2002 to that in 2005?
Your answer should be compact. 0.89. What is the ratio of the Savings(% of GNI) in Latvia in 2002 to that in 2005?
Ensure brevity in your answer.  0.41. What is the ratio of the Savings(% of GNI) of Russian Federation in 2002 to that in 2005?
Provide a succinct answer. 1.27. What is the ratio of the Savings(% of GNI) in Italy in 2002 to that in 2006?
Offer a terse response. 1.13. What is the ratio of the Savings(% of GNI) of Korea (Republic) in 2002 to that in 2006?
Keep it short and to the point. 0.92. What is the ratio of the Savings(% of GNI) of Latvia in 2002 to that in 2006?
Make the answer very short. 0.81. What is the ratio of the Savings(% of GNI) in Russian Federation in 2002 to that in 2006?
Offer a very short reply. 0.84. What is the ratio of the Savings(% of GNI) in Italy in 2003 to that in 2004?
Ensure brevity in your answer.  0.97. What is the ratio of the Savings(% of GNI) in Korea (Republic) in 2003 to that in 2004?
Ensure brevity in your answer.  0.87. What is the ratio of the Savings(% of GNI) of Latvia in 2003 to that in 2004?
Ensure brevity in your answer.  0.91. What is the ratio of the Savings(% of GNI) of Russian Federation in 2003 to that in 2004?
Ensure brevity in your answer.  0.64. What is the ratio of the Savings(% of GNI) in Italy in 2003 to that in 2005?
Keep it short and to the point. 1.1. What is the ratio of the Savings(% of GNI) of Korea (Republic) in 2003 to that in 2005?
Keep it short and to the point. 0.98. What is the ratio of the Savings(% of GNI) in Latvia in 2003 to that in 2005?
Keep it short and to the point. 0.66. What is the ratio of the Savings(% of GNI) in Russian Federation in 2003 to that in 2005?
Your answer should be compact. 0.93. What is the ratio of the Savings(% of GNI) in Italy in 2003 to that in 2006?
Give a very brief answer. 1.05. What is the ratio of the Savings(% of GNI) of Korea (Republic) in 2003 to that in 2006?
Offer a very short reply. 1.02. What is the ratio of the Savings(% of GNI) of Latvia in 2003 to that in 2006?
Provide a succinct answer. 1.3. What is the ratio of the Savings(% of GNI) of Russian Federation in 2003 to that in 2006?
Make the answer very short. 0.62. What is the ratio of the Savings(% of GNI) in Italy in 2004 to that in 2005?
Give a very brief answer. 1.13. What is the ratio of the Savings(% of GNI) in Korea (Republic) in 2004 to that in 2005?
Give a very brief answer. 1.13. What is the ratio of the Savings(% of GNI) of Latvia in 2004 to that in 2005?
Offer a very short reply. 0.72. What is the ratio of the Savings(% of GNI) in Russian Federation in 2004 to that in 2005?
Your response must be concise. 1.45. What is the ratio of the Savings(% of GNI) of Italy in 2004 to that in 2006?
Make the answer very short. 1.08. What is the ratio of the Savings(% of GNI) of Korea (Republic) in 2004 to that in 2006?
Your answer should be compact. 1.17. What is the ratio of the Savings(% of GNI) of Latvia in 2004 to that in 2006?
Offer a terse response. 1.43. What is the ratio of the Savings(% of GNI) in Russian Federation in 2004 to that in 2006?
Ensure brevity in your answer.  0.96. What is the ratio of the Savings(% of GNI) in Italy in 2005 to that in 2006?
Provide a short and direct response. 0.95. What is the ratio of the Savings(% of GNI) of Korea (Republic) in 2005 to that in 2006?
Your answer should be compact. 1.04. What is the ratio of the Savings(% of GNI) of Latvia in 2005 to that in 2006?
Ensure brevity in your answer.  1.99. What is the ratio of the Savings(% of GNI) in Russian Federation in 2005 to that in 2006?
Your response must be concise. 0.66. What is the difference between the highest and the second highest Savings(% of GNI) in Italy?
Your answer should be compact. 0.43. What is the difference between the highest and the second highest Savings(% of GNI) in Korea (Republic)?
Give a very brief answer. 2.29. What is the difference between the highest and the second highest Savings(% of GNI) of Latvia?
Give a very brief answer. 2.33. What is the difference between the highest and the second highest Savings(% of GNI) of Russian Federation?
Keep it short and to the point. 0.32. What is the difference between the highest and the lowest Savings(% of GNI) of Italy?
Your response must be concise. 1.97. What is the difference between the highest and the lowest Savings(% of GNI) in Korea (Republic)?
Make the answer very short. 4.68. What is the difference between the highest and the lowest Savings(% of GNI) of Latvia?
Offer a very short reply. 6.91. What is the difference between the highest and the lowest Savings(% of GNI) in Russian Federation?
Your answer should be compact. 3.3. 